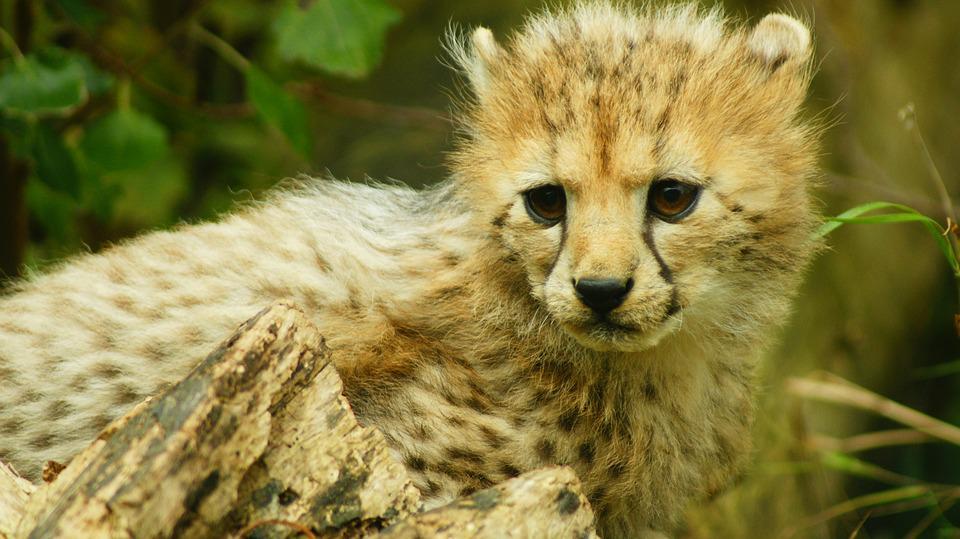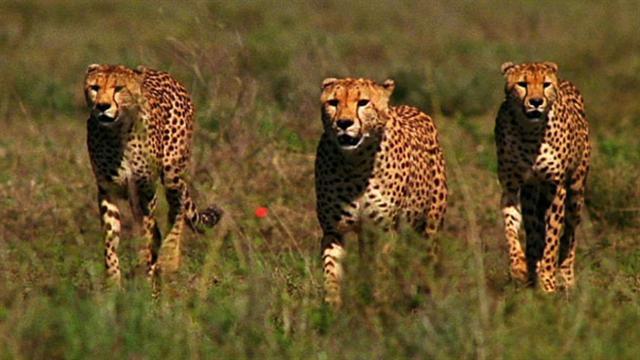The first image is the image on the left, the second image is the image on the right. Given the left and right images, does the statement "The image on the right contains no more than three cheetahs." hold true? Answer yes or no. Yes. 